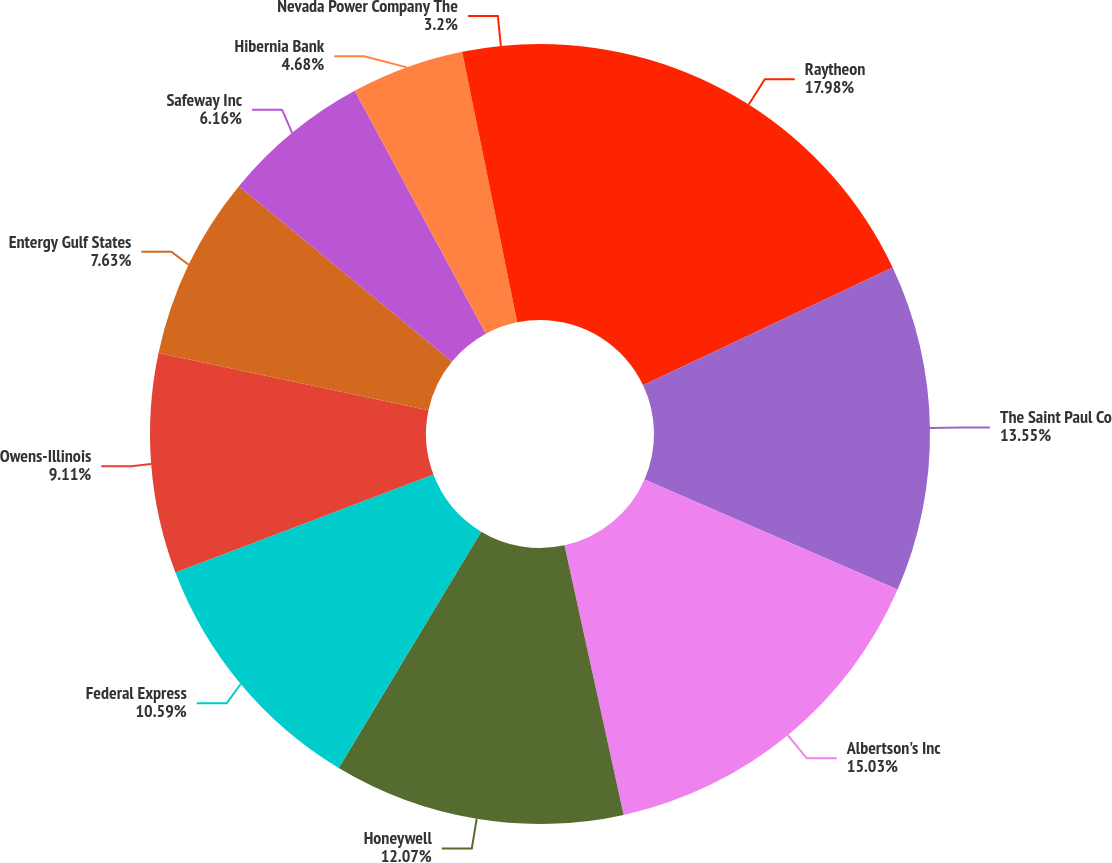<chart> <loc_0><loc_0><loc_500><loc_500><pie_chart><fcel>Raytheon<fcel>The Saint Paul Co<fcel>Albertson's Inc<fcel>Honeywell<fcel>Federal Express<fcel>Owens-Illinois<fcel>Entergy Gulf States<fcel>Safeway Inc<fcel>Hibernia Bank<fcel>Nevada Power Company The<nl><fcel>17.98%<fcel>13.55%<fcel>15.03%<fcel>12.07%<fcel>10.59%<fcel>9.11%<fcel>7.63%<fcel>6.16%<fcel>4.68%<fcel>3.2%<nl></chart> 